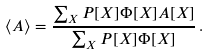Convert formula to latex. <formula><loc_0><loc_0><loc_500><loc_500>\langle A \rangle = \frac { \sum _ { X } P [ X ] \Phi [ X ] A [ X ] } { \sum _ { X } P [ X ] \Phi [ X ] } \, .</formula> 